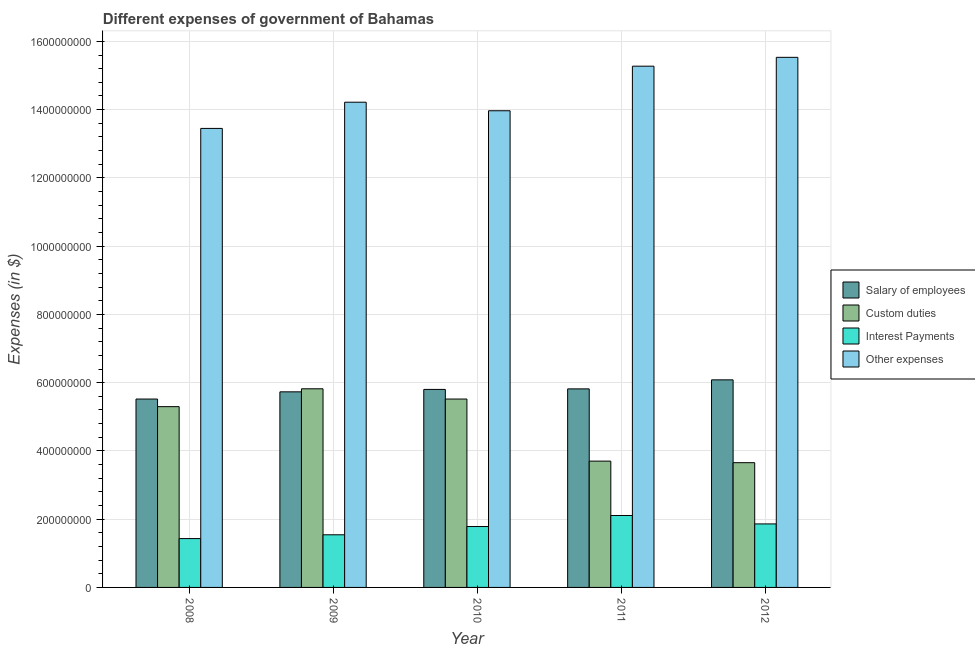How many different coloured bars are there?
Your answer should be compact. 4. Are the number of bars per tick equal to the number of legend labels?
Offer a very short reply. Yes. What is the label of the 3rd group of bars from the left?
Offer a very short reply. 2010. In how many cases, is the number of bars for a given year not equal to the number of legend labels?
Ensure brevity in your answer.  0. What is the amount spent on interest payments in 2010?
Your response must be concise. 1.78e+08. Across all years, what is the maximum amount spent on other expenses?
Your answer should be compact. 1.55e+09. Across all years, what is the minimum amount spent on interest payments?
Your response must be concise. 1.43e+08. In which year was the amount spent on interest payments maximum?
Your response must be concise. 2011. What is the total amount spent on salary of employees in the graph?
Offer a terse response. 2.90e+09. What is the difference between the amount spent on interest payments in 2009 and that in 2012?
Offer a very short reply. -3.19e+07. What is the difference between the amount spent on other expenses in 2008 and the amount spent on salary of employees in 2009?
Keep it short and to the point. -7.68e+07. What is the average amount spent on salary of employees per year?
Keep it short and to the point. 5.79e+08. In the year 2009, what is the difference between the amount spent on other expenses and amount spent on custom duties?
Your answer should be compact. 0. What is the ratio of the amount spent on custom duties in 2010 to that in 2012?
Provide a short and direct response. 1.51. Is the difference between the amount spent on custom duties in 2008 and 2009 greater than the difference between the amount spent on other expenses in 2008 and 2009?
Offer a terse response. No. What is the difference between the highest and the second highest amount spent on interest payments?
Ensure brevity in your answer.  2.47e+07. What is the difference between the highest and the lowest amount spent on salary of employees?
Your answer should be very brief. 5.62e+07. Is the sum of the amount spent on interest payments in 2008 and 2012 greater than the maximum amount spent on other expenses across all years?
Your answer should be very brief. Yes. Is it the case that in every year, the sum of the amount spent on other expenses and amount spent on salary of employees is greater than the sum of amount spent on custom duties and amount spent on interest payments?
Offer a very short reply. Yes. What does the 4th bar from the left in 2012 represents?
Provide a short and direct response. Other expenses. What does the 4th bar from the right in 2009 represents?
Offer a very short reply. Salary of employees. What is the difference between two consecutive major ticks on the Y-axis?
Keep it short and to the point. 2.00e+08. Are the values on the major ticks of Y-axis written in scientific E-notation?
Make the answer very short. No. Does the graph contain any zero values?
Keep it short and to the point. No. Where does the legend appear in the graph?
Offer a terse response. Center right. How many legend labels are there?
Your answer should be very brief. 4. What is the title of the graph?
Provide a short and direct response. Different expenses of government of Bahamas. Does "Methodology assessment" appear as one of the legend labels in the graph?
Keep it short and to the point. No. What is the label or title of the X-axis?
Keep it short and to the point. Year. What is the label or title of the Y-axis?
Provide a short and direct response. Expenses (in $). What is the Expenses (in $) of Salary of employees in 2008?
Keep it short and to the point. 5.52e+08. What is the Expenses (in $) of Custom duties in 2008?
Provide a short and direct response. 5.30e+08. What is the Expenses (in $) of Interest Payments in 2008?
Your answer should be very brief. 1.43e+08. What is the Expenses (in $) of Other expenses in 2008?
Your answer should be compact. 1.34e+09. What is the Expenses (in $) of Salary of employees in 2009?
Provide a succinct answer. 5.73e+08. What is the Expenses (in $) in Custom duties in 2009?
Your answer should be compact. 5.82e+08. What is the Expenses (in $) of Interest Payments in 2009?
Your answer should be very brief. 1.54e+08. What is the Expenses (in $) in Other expenses in 2009?
Make the answer very short. 1.42e+09. What is the Expenses (in $) of Salary of employees in 2010?
Make the answer very short. 5.80e+08. What is the Expenses (in $) in Custom duties in 2010?
Give a very brief answer. 5.52e+08. What is the Expenses (in $) in Interest Payments in 2010?
Keep it short and to the point. 1.78e+08. What is the Expenses (in $) of Other expenses in 2010?
Ensure brevity in your answer.  1.40e+09. What is the Expenses (in $) in Salary of employees in 2011?
Make the answer very short. 5.82e+08. What is the Expenses (in $) in Custom duties in 2011?
Provide a short and direct response. 3.70e+08. What is the Expenses (in $) of Interest Payments in 2011?
Ensure brevity in your answer.  2.11e+08. What is the Expenses (in $) of Other expenses in 2011?
Provide a succinct answer. 1.53e+09. What is the Expenses (in $) in Salary of employees in 2012?
Make the answer very short. 6.08e+08. What is the Expenses (in $) of Custom duties in 2012?
Your response must be concise. 3.66e+08. What is the Expenses (in $) in Interest Payments in 2012?
Ensure brevity in your answer.  1.86e+08. What is the Expenses (in $) in Other expenses in 2012?
Offer a very short reply. 1.55e+09. Across all years, what is the maximum Expenses (in $) of Salary of employees?
Your answer should be compact. 6.08e+08. Across all years, what is the maximum Expenses (in $) in Custom duties?
Make the answer very short. 5.82e+08. Across all years, what is the maximum Expenses (in $) in Interest Payments?
Offer a terse response. 2.11e+08. Across all years, what is the maximum Expenses (in $) of Other expenses?
Make the answer very short. 1.55e+09. Across all years, what is the minimum Expenses (in $) of Salary of employees?
Offer a terse response. 5.52e+08. Across all years, what is the minimum Expenses (in $) in Custom duties?
Offer a terse response. 3.66e+08. Across all years, what is the minimum Expenses (in $) in Interest Payments?
Offer a very short reply. 1.43e+08. Across all years, what is the minimum Expenses (in $) of Other expenses?
Ensure brevity in your answer.  1.34e+09. What is the total Expenses (in $) in Salary of employees in the graph?
Offer a terse response. 2.90e+09. What is the total Expenses (in $) of Custom duties in the graph?
Provide a short and direct response. 2.40e+09. What is the total Expenses (in $) of Interest Payments in the graph?
Give a very brief answer. 8.73e+08. What is the total Expenses (in $) in Other expenses in the graph?
Ensure brevity in your answer.  7.24e+09. What is the difference between the Expenses (in $) of Salary of employees in 2008 and that in 2009?
Offer a terse response. -2.11e+07. What is the difference between the Expenses (in $) of Custom duties in 2008 and that in 2009?
Your answer should be compact. -5.23e+07. What is the difference between the Expenses (in $) in Interest Payments in 2008 and that in 2009?
Make the answer very short. -1.11e+07. What is the difference between the Expenses (in $) of Other expenses in 2008 and that in 2009?
Provide a succinct answer. -7.68e+07. What is the difference between the Expenses (in $) of Salary of employees in 2008 and that in 2010?
Provide a succinct answer. -2.82e+07. What is the difference between the Expenses (in $) of Custom duties in 2008 and that in 2010?
Provide a short and direct response. -2.23e+07. What is the difference between the Expenses (in $) in Interest Payments in 2008 and that in 2010?
Keep it short and to the point. -3.53e+07. What is the difference between the Expenses (in $) of Other expenses in 2008 and that in 2010?
Give a very brief answer. -5.18e+07. What is the difference between the Expenses (in $) in Salary of employees in 2008 and that in 2011?
Offer a terse response. -2.98e+07. What is the difference between the Expenses (in $) in Custom duties in 2008 and that in 2011?
Provide a short and direct response. 1.60e+08. What is the difference between the Expenses (in $) in Interest Payments in 2008 and that in 2011?
Ensure brevity in your answer.  -6.76e+07. What is the difference between the Expenses (in $) in Other expenses in 2008 and that in 2011?
Your response must be concise. -1.82e+08. What is the difference between the Expenses (in $) in Salary of employees in 2008 and that in 2012?
Give a very brief answer. -5.62e+07. What is the difference between the Expenses (in $) in Custom duties in 2008 and that in 2012?
Your response must be concise. 1.64e+08. What is the difference between the Expenses (in $) of Interest Payments in 2008 and that in 2012?
Give a very brief answer. -4.30e+07. What is the difference between the Expenses (in $) of Other expenses in 2008 and that in 2012?
Make the answer very short. -2.08e+08. What is the difference between the Expenses (in $) of Salary of employees in 2009 and that in 2010?
Provide a succinct answer. -7.13e+06. What is the difference between the Expenses (in $) in Custom duties in 2009 and that in 2010?
Provide a succinct answer. 3.00e+07. What is the difference between the Expenses (in $) of Interest Payments in 2009 and that in 2010?
Provide a succinct answer. -2.42e+07. What is the difference between the Expenses (in $) of Other expenses in 2009 and that in 2010?
Provide a short and direct response. 2.50e+07. What is the difference between the Expenses (in $) in Salary of employees in 2009 and that in 2011?
Your response must be concise. -8.68e+06. What is the difference between the Expenses (in $) in Custom duties in 2009 and that in 2011?
Ensure brevity in your answer.  2.12e+08. What is the difference between the Expenses (in $) in Interest Payments in 2009 and that in 2011?
Offer a very short reply. -5.65e+07. What is the difference between the Expenses (in $) in Other expenses in 2009 and that in 2011?
Your answer should be very brief. -1.06e+08. What is the difference between the Expenses (in $) of Salary of employees in 2009 and that in 2012?
Keep it short and to the point. -3.51e+07. What is the difference between the Expenses (in $) in Custom duties in 2009 and that in 2012?
Provide a short and direct response. 2.16e+08. What is the difference between the Expenses (in $) in Interest Payments in 2009 and that in 2012?
Ensure brevity in your answer.  -3.19e+07. What is the difference between the Expenses (in $) of Other expenses in 2009 and that in 2012?
Provide a succinct answer. -1.32e+08. What is the difference between the Expenses (in $) of Salary of employees in 2010 and that in 2011?
Provide a succinct answer. -1.55e+06. What is the difference between the Expenses (in $) of Custom duties in 2010 and that in 2011?
Ensure brevity in your answer.  1.82e+08. What is the difference between the Expenses (in $) in Interest Payments in 2010 and that in 2011?
Provide a succinct answer. -3.23e+07. What is the difference between the Expenses (in $) in Other expenses in 2010 and that in 2011?
Your answer should be compact. -1.31e+08. What is the difference between the Expenses (in $) of Salary of employees in 2010 and that in 2012?
Provide a short and direct response. -2.80e+07. What is the difference between the Expenses (in $) of Custom duties in 2010 and that in 2012?
Keep it short and to the point. 1.86e+08. What is the difference between the Expenses (in $) in Interest Payments in 2010 and that in 2012?
Your answer should be compact. -7.64e+06. What is the difference between the Expenses (in $) of Other expenses in 2010 and that in 2012?
Give a very brief answer. -1.57e+08. What is the difference between the Expenses (in $) in Salary of employees in 2011 and that in 2012?
Offer a terse response. -2.64e+07. What is the difference between the Expenses (in $) in Custom duties in 2011 and that in 2012?
Your answer should be very brief. 4.57e+06. What is the difference between the Expenses (in $) in Interest Payments in 2011 and that in 2012?
Ensure brevity in your answer.  2.47e+07. What is the difference between the Expenses (in $) in Other expenses in 2011 and that in 2012?
Your answer should be compact. -2.60e+07. What is the difference between the Expenses (in $) of Salary of employees in 2008 and the Expenses (in $) of Custom duties in 2009?
Provide a succinct answer. -3.00e+07. What is the difference between the Expenses (in $) of Salary of employees in 2008 and the Expenses (in $) of Interest Payments in 2009?
Make the answer very short. 3.98e+08. What is the difference between the Expenses (in $) in Salary of employees in 2008 and the Expenses (in $) in Other expenses in 2009?
Keep it short and to the point. -8.70e+08. What is the difference between the Expenses (in $) in Custom duties in 2008 and the Expenses (in $) in Interest Payments in 2009?
Ensure brevity in your answer.  3.75e+08. What is the difference between the Expenses (in $) of Custom duties in 2008 and the Expenses (in $) of Other expenses in 2009?
Give a very brief answer. -8.92e+08. What is the difference between the Expenses (in $) in Interest Payments in 2008 and the Expenses (in $) in Other expenses in 2009?
Your response must be concise. -1.28e+09. What is the difference between the Expenses (in $) in Salary of employees in 2008 and the Expenses (in $) in Custom duties in 2010?
Make the answer very short. -1.10e+04. What is the difference between the Expenses (in $) of Salary of employees in 2008 and the Expenses (in $) of Interest Payments in 2010?
Your answer should be compact. 3.74e+08. What is the difference between the Expenses (in $) in Salary of employees in 2008 and the Expenses (in $) in Other expenses in 2010?
Make the answer very short. -8.45e+08. What is the difference between the Expenses (in $) of Custom duties in 2008 and the Expenses (in $) of Interest Payments in 2010?
Keep it short and to the point. 3.51e+08. What is the difference between the Expenses (in $) of Custom duties in 2008 and the Expenses (in $) of Other expenses in 2010?
Your response must be concise. -8.67e+08. What is the difference between the Expenses (in $) in Interest Payments in 2008 and the Expenses (in $) in Other expenses in 2010?
Make the answer very short. -1.25e+09. What is the difference between the Expenses (in $) of Salary of employees in 2008 and the Expenses (in $) of Custom duties in 2011?
Give a very brief answer. 1.82e+08. What is the difference between the Expenses (in $) in Salary of employees in 2008 and the Expenses (in $) in Interest Payments in 2011?
Provide a short and direct response. 3.41e+08. What is the difference between the Expenses (in $) of Salary of employees in 2008 and the Expenses (in $) of Other expenses in 2011?
Provide a short and direct response. -9.75e+08. What is the difference between the Expenses (in $) in Custom duties in 2008 and the Expenses (in $) in Interest Payments in 2011?
Offer a very short reply. 3.19e+08. What is the difference between the Expenses (in $) in Custom duties in 2008 and the Expenses (in $) in Other expenses in 2011?
Give a very brief answer. -9.98e+08. What is the difference between the Expenses (in $) in Interest Payments in 2008 and the Expenses (in $) in Other expenses in 2011?
Ensure brevity in your answer.  -1.38e+09. What is the difference between the Expenses (in $) in Salary of employees in 2008 and the Expenses (in $) in Custom duties in 2012?
Ensure brevity in your answer.  1.86e+08. What is the difference between the Expenses (in $) of Salary of employees in 2008 and the Expenses (in $) of Interest Payments in 2012?
Offer a very short reply. 3.66e+08. What is the difference between the Expenses (in $) of Salary of employees in 2008 and the Expenses (in $) of Other expenses in 2012?
Offer a terse response. -1.00e+09. What is the difference between the Expenses (in $) of Custom duties in 2008 and the Expenses (in $) of Interest Payments in 2012?
Your answer should be very brief. 3.44e+08. What is the difference between the Expenses (in $) in Custom duties in 2008 and the Expenses (in $) in Other expenses in 2012?
Keep it short and to the point. -1.02e+09. What is the difference between the Expenses (in $) of Interest Payments in 2008 and the Expenses (in $) of Other expenses in 2012?
Ensure brevity in your answer.  -1.41e+09. What is the difference between the Expenses (in $) of Salary of employees in 2009 and the Expenses (in $) of Custom duties in 2010?
Keep it short and to the point. 2.11e+07. What is the difference between the Expenses (in $) in Salary of employees in 2009 and the Expenses (in $) in Interest Payments in 2010?
Keep it short and to the point. 3.95e+08. What is the difference between the Expenses (in $) of Salary of employees in 2009 and the Expenses (in $) of Other expenses in 2010?
Offer a very short reply. -8.24e+08. What is the difference between the Expenses (in $) of Custom duties in 2009 and the Expenses (in $) of Interest Payments in 2010?
Offer a very short reply. 4.04e+08. What is the difference between the Expenses (in $) in Custom duties in 2009 and the Expenses (in $) in Other expenses in 2010?
Offer a terse response. -8.15e+08. What is the difference between the Expenses (in $) of Interest Payments in 2009 and the Expenses (in $) of Other expenses in 2010?
Provide a short and direct response. -1.24e+09. What is the difference between the Expenses (in $) in Salary of employees in 2009 and the Expenses (in $) in Custom duties in 2011?
Your answer should be very brief. 2.03e+08. What is the difference between the Expenses (in $) of Salary of employees in 2009 and the Expenses (in $) of Interest Payments in 2011?
Keep it short and to the point. 3.62e+08. What is the difference between the Expenses (in $) of Salary of employees in 2009 and the Expenses (in $) of Other expenses in 2011?
Offer a terse response. -9.54e+08. What is the difference between the Expenses (in $) in Custom duties in 2009 and the Expenses (in $) in Interest Payments in 2011?
Your answer should be compact. 3.71e+08. What is the difference between the Expenses (in $) of Custom duties in 2009 and the Expenses (in $) of Other expenses in 2011?
Keep it short and to the point. -9.45e+08. What is the difference between the Expenses (in $) in Interest Payments in 2009 and the Expenses (in $) in Other expenses in 2011?
Offer a terse response. -1.37e+09. What is the difference between the Expenses (in $) of Salary of employees in 2009 and the Expenses (in $) of Custom duties in 2012?
Your answer should be very brief. 2.08e+08. What is the difference between the Expenses (in $) of Salary of employees in 2009 and the Expenses (in $) of Interest Payments in 2012?
Provide a short and direct response. 3.87e+08. What is the difference between the Expenses (in $) in Salary of employees in 2009 and the Expenses (in $) in Other expenses in 2012?
Provide a succinct answer. -9.80e+08. What is the difference between the Expenses (in $) of Custom duties in 2009 and the Expenses (in $) of Interest Payments in 2012?
Provide a succinct answer. 3.96e+08. What is the difference between the Expenses (in $) in Custom duties in 2009 and the Expenses (in $) in Other expenses in 2012?
Offer a very short reply. -9.71e+08. What is the difference between the Expenses (in $) of Interest Payments in 2009 and the Expenses (in $) of Other expenses in 2012?
Ensure brevity in your answer.  -1.40e+09. What is the difference between the Expenses (in $) in Salary of employees in 2010 and the Expenses (in $) in Custom duties in 2011?
Your answer should be very brief. 2.10e+08. What is the difference between the Expenses (in $) in Salary of employees in 2010 and the Expenses (in $) in Interest Payments in 2011?
Your answer should be compact. 3.69e+08. What is the difference between the Expenses (in $) of Salary of employees in 2010 and the Expenses (in $) of Other expenses in 2011?
Give a very brief answer. -9.47e+08. What is the difference between the Expenses (in $) of Custom duties in 2010 and the Expenses (in $) of Interest Payments in 2011?
Provide a short and direct response. 3.41e+08. What is the difference between the Expenses (in $) in Custom duties in 2010 and the Expenses (in $) in Other expenses in 2011?
Give a very brief answer. -9.75e+08. What is the difference between the Expenses (in $) in Interest Payments in 2010 and the Expenses (in $) in Other expenses in 2011?
Offer a very short reply. -1.35e+09. What is the difference between the Expenses (in $) of Salary of employees in 2010 and the Expenses (in $) of Custom duties in 2012?
Ensure brevity in your answer.  2.15e+08. What is the difference between the Expenses (in $) of Salary of employees in 2010 and the Expenses (in $) of Interest Payments in 2012?
Your answer should be very brief. 3.94e+08. What is the difference between the Expenses (in $) of Salary of employees in 2010 and the Expenses (in $) of Other expenses in 2012?
Your response must be concise. -9.73e+08. What is the difference between the Expenses (in $) of Custom duties in 2010 and the Expenses (in $) of Interest Payments in 2012?
Ensure brevity in your answer.  3.66e+08. What is the difference between the Expenses (in $) of Custom duties in 2010 and the Expenses (in $) of Other expenses in 2012?
Offer a terse response. -1.00e+09. What is the difference between the Expenses (in $) in Interest Payments in 2010 and the Expenses (in $) in Other expenses in 2012?
Your answer should be very brief. -1.37e+09. What is the difference between the Expenses (in $) of Salary of employees in 2011 and the Expenses (in $) of Custom duties in 2012?
Keep it short and to the point. 2.16e+08. What is the difference between the Expenses (in $) in Salary of employees in 2011 and the Expenses (in $) in Interest Payments in 2012?
Your answer should be very brief. 3.96e+08. What is the difference between the Expenses (in $) of Salary of employees in 2011 and the Expenses (in $) of Other expenses in 2012?
Give a very brief answer. -9.72e+08. What is the difference between the Expenses (in $) of Custom duties in 2011 and the Expenses (in $) of Interest Payments in 2012?
Keep it short and to the point. 1.84e+08. What is the difference between the Expenses (in $) of Custom duties in 2011 and the Expenses (in $) of Other expenses in 2012?
Your answer should be compact. -1.18e+09. What is the difference between the Expenses (in $) of Interest Payments in 2011 and the Expenses (in $) of Other expenses in 2012?
Keep it short and to the point. -1.34e+09. What is the average Expenses (in $) in Salary of employees per year?
Offer a terse response. 5.79e+08. What is the average Expenses (in $) in Custom duties per year?
Give a very brief answer. 4.80e+08. What is the average Expenses (in $) of Interest Payments per year?
Provide a succinct answer. 1.75e+08. What is the average Expenses (in $) of Other expenses per year?
Your response must be concise. 1.45e+09. In the year 2008, what is the difference between the Expenses (in $) in Salary of employees and Expenses (in $) in Custom duties?
Keep it short and to the point. 2.23e+07. In the year 2008, what is the difference between the Expenses (in $) of Salary of employees and Expenses (in $) of Interest Payments?
Your answer should be compact. 4.09e+08. In the year 2008, what is the difference between the Expenses (in $) of Salary of employees and Expenses (in $) of Other expenses?
Your answer should be compact. -7.93e+08. In the year 2008, what is the difference between the Expenses (in $) of Custom duties and Expenses (in $) of Interest Payments?
Provide a short and direct response. 3.87e+08. In the year 2008, what is the difference between the Expenses (in $) of Custom duties and Expenses (in $) of Other expenses?
Provide a short and direct response. -8.15e+08. In the year 2008, what is the difference between the Expenses (in $) of Interest Payments and Expenses (in $) of Other expenses?
Keep it short and to the point. -1.20e+09. In the year 2009, what is the difference between the Expenses (in $) of Salary of employees and Expenses (in $) of Custom duties?
Your response must be concise. -8.94e+06. In the year 2009, what is the difference between the Expenses (in $) in Salary of employees and Expenses (in $) in Interest Payments?
Your answer should be very brief. 4.19e+08. In the year 2009, what is the difference between the Expenses (in $) in Salary of employees and Expenses (in $) in Other expenses?
Provide a succinct answer. -8.49e+08. In the year 2009, what is the difference between the Expenses (in $) in Custom duties and Expenses (in $) in Interest Payments?
Keep it short and to the point. 4.28e+08. In the year 2009, what is the difference between the Expenses (in $) in Custom duties and Expenses (in $) in Other expenses?
Your response must be concise. -8.40e+08. In the year 2009, what is the difference between the Expenses (in $) in Interest Payments and Expenses (in $) in Other expenses?
Offer a terse response. -1.27e+09. In the year 2010, what is the difference between the Expenses (in $) in Salary of employees and Expenses (in $) in Custom duties?
Your answer should be compact. 2.82e+07. In the year 2010, what is the difference between the Expenses (in $) of Salary of employees and Expenses (in $) of Interest Payments?
Your answer should be very brief. 4.02e+08. In the year 2010, what is the difference between the Expenses (in $) in Salary of employees and Expenses (in $) in Other expenses?
Provide a succinct answer. -8.17e+08. In the year 2010, what is the difference between the Expenses (in $) in Custom duties and Expenses (in $) in Interest Payments?
Offer a terse response. 3.74e+08. In the year 2010, what is the difference between the Expenses (in $) of Custom duties and Expenses (in $) of Other expenses?
Offer a terse response. -8.45e+08. In the year 2010, what is the difference between the Expenses (in $) of Interest Payments and Expenses (in $) of Other expenses?
Offer a terse response. -1.22e+09. In the year 2011, what is the difference between the Expenses (in $) in Salary of employees and Expenses (in $) in Custom duties?
Make the answer very short. 2.12e+08. In the year 2011, what is the difference between the Expenses (in $) in Salary of employees and Expenses (in $) in Interest Payments?
Offer a very short reply. 3.71e+08. In the year 2011, what is the difference between the Expenses (in $) of Salary of employees and Expenses (in $) of Other expenses?
Offer a very short reply. -9.46e+08. In the year 2011, what is the difference between the Expenses (in $) of Custom duties and Expenses (in $) of Interest Payments?
Provide a short and direct response. 1.59e+08. In the year 2011, what is the difference between the Expenses (in $) in Custom duties and Expenses (in $) in Other expenses?
Keep it short and to the point. -1.16e+09. In the year 2011, what is the difference between the Expenses (in $) of Interest Payments and Expenses (in $) of Other expenses?
Offer a very short reply. -1.32e+09. In the year 2012, what is the difference between the Expenses (in $) in Salary of employees and Expenses (in $) in Custom duties?
Offer a terse response. 2.43e+08. In the year 2012, what is the difference between the Expenses (in $) of Salary of employees and Expenses (in $) of Interest Payments?
Keep it short and to the point. 4.22e+08. In the year 2012, what is the difference between the Expenses (in $) in Salary of employees and Expenses (in $) in Other expenses?
Ensure brevity in your answer.  -9.45e+08. In the year 2012, what is the difference between the Expenses (in $) in Custom duties and Expenses (in $) in Interest Payments?
Offer a terse response. 1.79e+08. In the year 2012, what is the difference between the Expenses (in $) of Custom duties and Expenses (in $) of Other expenses?
Your answer should be compact. -1.19e+09. In the year 2012, what is the difference between the Expenses (in $) of Interest Payments and Expenses (in $) of Other expenses?
Your answer should be compact. -1.37e+09. What is the ratio of the Expenses (in $) in Salary of employees in 2008 to that in 2009?
Offer a very short reply. 0.96. What is the ratio of the Expenses (in $) of Custom duties in 2008 to that in 2009?
Give a very brief answer. 0.91. What is the ratio of the Expenses (in $) in Interest Payments in 2008 to that in 2009?
Your response must be concise. 0.93. What is the ratio of the Expenses (in $) of Other expenses in 2008 to that in 2009?
Keep it short and to the point. 0.95. What is the ratio of the Expenses (in $) of Salary of employees in 2008 to that in 2010?
Your answer should be very brief. 0.95. What is the ratio of the Expenses (in $) in Custom duties in 2008 to that in 2010?
Offer a very short reply. 0.96. What is the ratio of the Expenses (in $) in Interest Payments in 2008 to that in 2010?
Provide a succinct answer. 0.8. What is the ratio of the Expenses (in $) in Other expenses in 2008 to that in 2010?
Make the answer very short. 0.96. What is the ratio of the Expenses (in $) of Salary of employees in 2008 to that in 2011?
Your response must be concise. 0.95. What is the ratio of the Expenses (in $) of Custom duties in 2008 to that in 2011?
Provide a short and direct response. 1.43. What is the ratio of the Expenses (in $) in Interest Payments in 2008 to that in 2011?
Provide a short and direct response. 0.68. What is the ratio of the Expenses (in $) in Other expenses in 2008 to that in 2011?
Make the answer very short. 0.88. What is the ratio of the Expenses (in $) of Salary of employees in 2008 to that in 2012?
Make the answer very short. 0.91. What is the ratio of the Expenses (in $) in Custom duties in 2008 to that in 2012?
Provide a succinct answer. 1.45. What is the ratio of the Expenses (in $) in Interest Payments in 2008 to that in 2012?
Your answer should be compact. 0.77. What is the ratio of the Expenses (in $) of Other expenses in 2008 to that in 2012?
Offer a very short reply. 0.87. What is the ratio of the Expenses (in $) in Custom duties in 2009 to that in 2010?
Give a very brief answer. 1.05. What is the ratio of the Expenses (in $) in Interest Payments in 2009 to that in 2010?
Ensure brevity in your answer.  0.86. What is the ratio of the Expenses (in $) in Other expenses in 2009 to that in 2010?
Your response must be concise. 1.02. What is the ratio of the Expenses (in $) of Salary of employees in 2009 to that in 2011?
Ensure brevity in your answer.  0.99. What is the ratio of the Expenses (in $) of Custom duties in 2009 to that in 2011?
Provide a short and direct response. 1.57. What is the ratio of the Expenses (in $) of Interest Payments in 2009 to that in 2011?
Keep it short and to the point. 0.73. What is the ratio of the Expenses (in $) in Other expenses in 2009 to that in 2011?
Your answer should be compact. 0.93. What is the ratio of the Expenses (in $) in Salary of employees in 2009 to that in 2012?
Make the answer very short. 0.94. What is the ratio of the Expenses (in $) in Custom duties in 2009 to that in 2012?
Your answer should be very brief. 1.59. What is the ratio of the Expenses (in $) in Interest Payments in 2009 to that in 2012?
Offer a very short reply. 0.83. What is the ratio of the Expenses (in $) of Other expenses in 2009 to that in 2012?
Provide a short and direct response. 0.92. What is the ratio of the Expenses (in $) of Custom duties in 2010 to that in 2011?
Ensure brevity in your answer.  1.49. What is the ratio of the Expenses (in $) of Interest Payments in 2010 to that in 2011?
Offer a very short reply. 0.85. What is the ratio of the Expenses (in $) of Other expenses in 2010 to that in 2011?
Make the answer very short. 0.91. What is the ratio of the Expenses (in $) in Salary of employees in 2010 to that in 2012?
Your answer should be compact. 0.95. What is the ratio of the Expenses (in $) of Custom duties in 2010 to that in 2012?
Keep it short and to the point. 1.51. What is the ratio of the Expenses (in $) in Other expenses in 2010 to that in 2012?
Keep it short and to the point. 0.9. What is the ratio of the Expenses (in $) of Salary of employees in 2011 to that in 2012?
Ensure brevity in your answer.  0.96. What is the ratio of the Expenses (in $) in Custom duties in 2011 to that in 2012?
Give a very brief answer. 1.01. What is the ratio of the Expenses (in $) of Interest Payments in 2011 to that in 2012?
Keep it short and to the point. 1.13. What is the ratio of the Expenses (in $) of Other expenses in 2011 to that in 2012?
Keep it short and to the point. 0.98. What is the difference between the highest and the second highest Expenses (in $) in Salary of employees?
Offer a very short reply. 2.64e+07. What is the difference between the highest and the second highest Expenses (in $) in Custom duties?
Your response must be concise. 3.00e+07. What is the difference between the highest and the second highest Expenses (in $) in Interest Payments?
Offer a very short reply. 2.47e+07. What is the difference between the highest and the second highest Expenses (in $) of Other expenses?
Your answer should be very brief. 2.60e+07. What is the difference between the highest and the lowest Expenses (in $) in Salary of employees?
Provide a succinct answer. 5.62e+07. What is the difference between the highest and the lowest Expenses (in $) of Custom duties?
Keep it short and to the point. 2.16e+08. What is the difference between the highest and the lowest Expenses (in $) in Interest Payments?
Your answer should be very brief. 6.76e+07. What is the difference between the highest and the lowest Expenses (in $) in Other expenses?
Provide a short and direct response. 2.08e+08. 